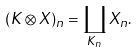Convert formula to latex. <formula><loc_0><loc_0><loc_500><loc_500>( K \otimes X ) _ { n } = \coprod _ { K _ { n } } X _ { n } .</formula> 